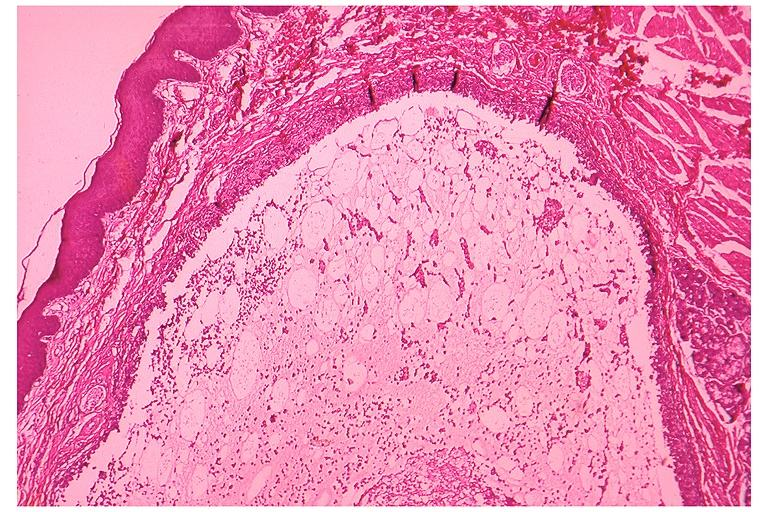does cat show mucocele?
Answer the question using a single word or phrase. No 